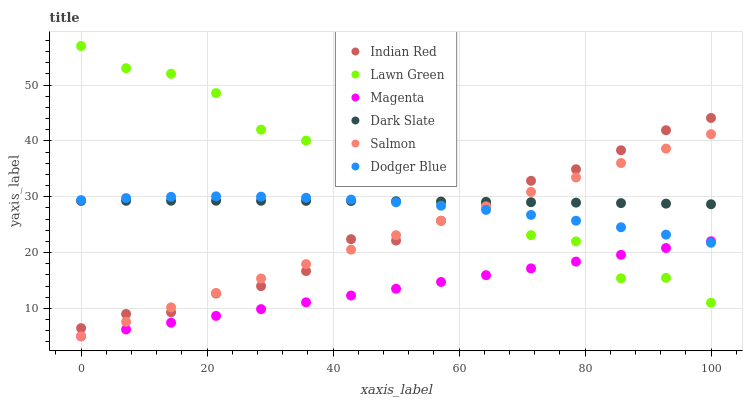Does Magenta have the minimum area under the curve?
Answer yes or no. Yes. Does Lawn Green have the maximum area under the curve?
Answer yes or no. Yes. Does Salmon have the minimum area under the curve?
Answer yes or no. No. Does Salmon have the maximum area under the curve?
Answer yes or no. No. Is Magenta the smoothest?
Answer yes or no. Yes. Is Lawn Green the roughest?
Answer yes or no. Yes. Is Salmon the smoothest?
Answer yes or no. No. Is Salmon the roughest?
Answer yes or no. No. Does Salmon have the lowest value?
Answer yes or no. Yes. Does Dark Slate have the lowest value?
Answer yes or no. No. Does Lawn Green have the highest value?
Answer yes or no. Yes. Does Salmon have the highest value?
Answer yes or no. No. Is Magenta less than Dark Slate?
Answer yes or no. Yes. Is Dark Slate greater than Magenta?
Answer yes or no. Yes. Does Magenta intersect Lawn Green?
Answer yes or no. Yes. Is Magenta less than Lawn Green?
Answer yes or no. No. Is Magenta greater than Lawn Green?
Answer yes or no. No. Does Magenta intersect Dark Slate?
Answer yes or no. No. 